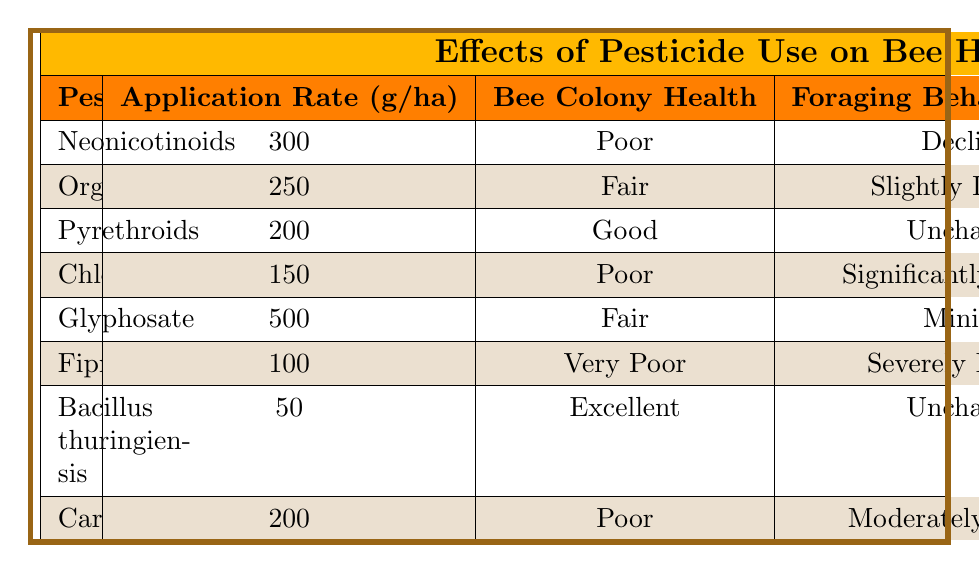What is the application rate of Neonicotinoids? The table shows the row for Neonicotinoids with its corresponding application rate. It clearly states an application rate of 300 g/ha.
Answer: 300 g/ha Which pesticide has the highest survival rate? By comparing the survival rates of all the pesticides listed in the table, Bacillus thuringiensis has the highest survival rate at 95%.
Answer: 95% Is the foraging behavior impact for Pyrethroids unchanged? Looking at the table, the foraging behavior impact for Pyrethroids is noted as "Unchanged". Therefore, the statement is true.
Answer: Yes What is the average survival rate of pesticides categorized as "Poor" for bee colony health? The survival rates for "Poor" categorized pesticides are 60% (Neonicotinoids), 50% (Chlorpyrifos), and 55% (Carbaryl). To find the average: (60 + 50 + 55) / 3 = 55%.
Answer: 55% Which pesticide has a "Very Poor" health status and what is its application rate? Fipronil is listed under “Very Poor” bee colony health, and its application rate is 100 g/ha according to the table.
Answer: Fipronil, 100 g/ha If we consider the "Fair" bee colony health pesticides, what is their average application rate? There are two pesticides listed as "Fair" (Organophosphates and Glyphosate) with application rates of 250 g/ha and 500 g/ha respectively. The average application rate is (250 + 500) / 2 = 375 g/ha.
Answer: 375 g/ha Do any of the pesticides lead to an unchanged foraging behavior? By examining the table, both Pyrethroids and Bacillus thuringiensis have "Unchanged" foraging behavior impact. Thus, the answer is yes.
Answer: Yes What is the difference in survival rates between the pesticides with "Excellent" and "Very Poor" colony health? The survival rate for Bacillus thuringiensis, categorized as "Excellent," is 95%. The survival rate for Fipronil, with "Very Poor" health, is 35%. The difference is 95 - 35 = 60%.
Answer: 60% 